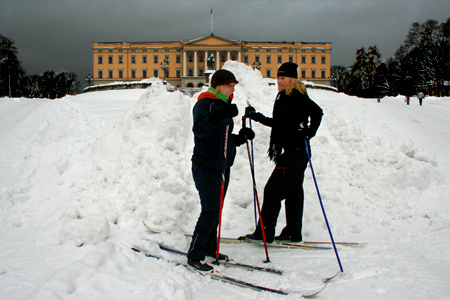Who do you think is in front of the building? The girl is in front of the building. 